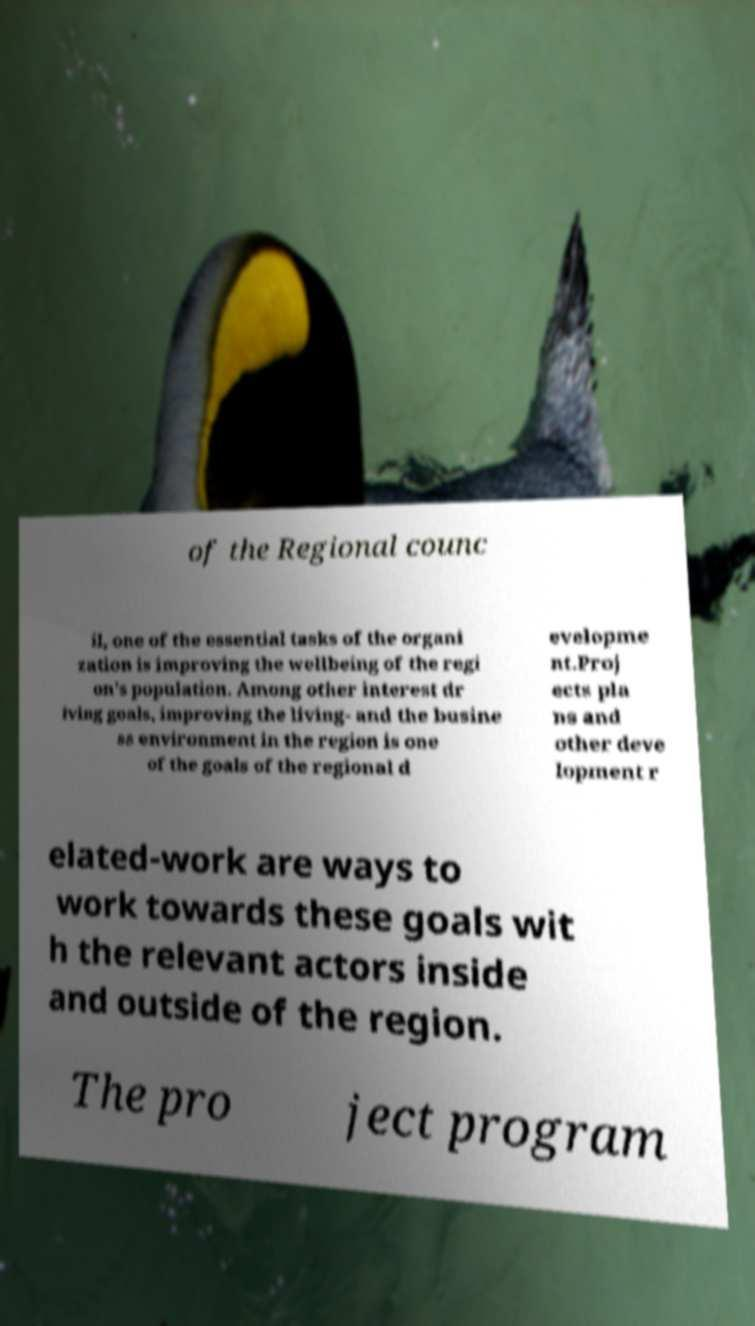There's text embedded in this image that I need extracted. Can you transcribe it verbatim? of the Regional counc il, one of the essential tasks of the organi zation is improving the wellbeing of the regi on's population. Among other interest dr iving goals, improving the living- and the busine ss environment in the region is one of the goals of the regional d evelopme nt.Proj ects pla ns and other deve lopment r elated-work are ways to work towards these goals wit h the relevant actors inside and outside of the region. The pro ject program 